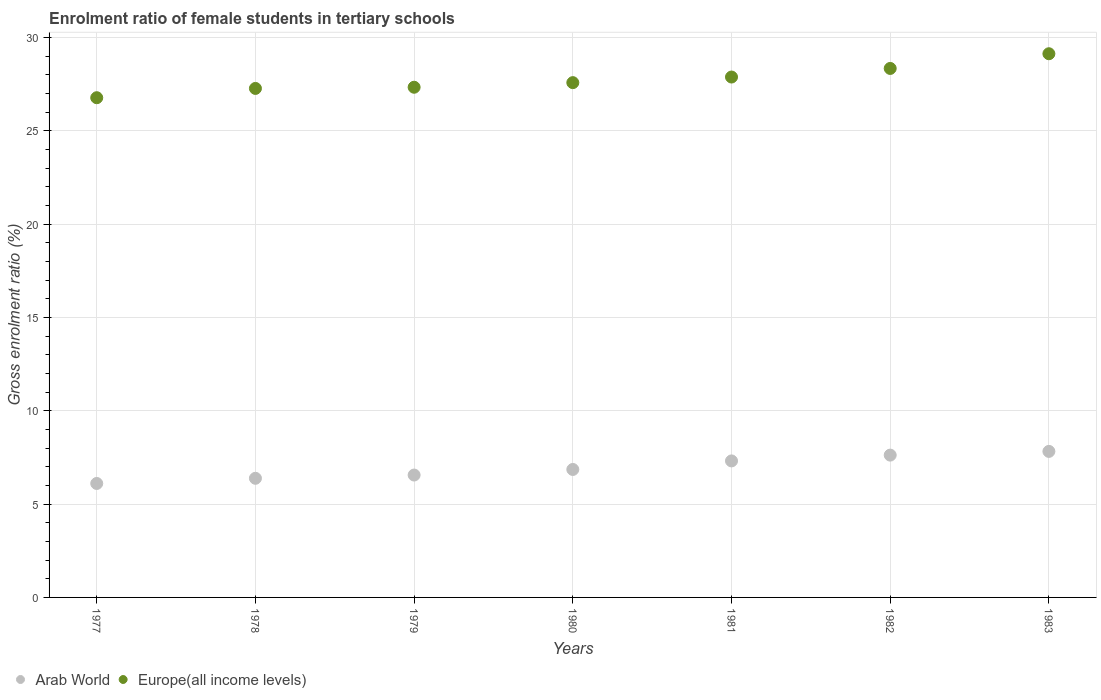How many different coloured dotlines are there?
Provide a short and direct response. 2. What is the enrolment ratio of female students in tertiary schools in Europe(all income levels) in 1980?
Your answer should be compact. 27.59. Across all years, what is the maximum enrolment ratio of female students in tertiary schools in Arab World?
Provide a succinct answer. 7.83. Across all years, what is the minimum enrolment ratio of female students in tertiary schools in Arab World?
Offer a very short reply. 6.11. In which year was the enrolment ratio of female students in tertiary schools in Europe(all income levels) maximum?
Your answer should be compact. 1983. What is the total enrolment ratio of female students in tertiary schools in Europe(all income levels) in the graph?
Offer a terse response. 194.34. What is the difference between the enrolment ratio of female students in tertiary schools in Europe(all income levels) in 1980 and that in 1981?
Ensure brevity in your answer.  -0.3. What is the difference between the enrolment ratio of female students in tertiary schools in Arab World in 1979 and the enrolment ratio of female students in tertiary schools in Europe(all income levels) in 1981?
Ensure brevity in your answer.  -21.33. What is the average enrolment ratio of female students in tertiary schools in Europe(all income levels) per year?
Ensure brevity in your answer.  27.76. In the year 1979, what is the difference between the enrolment ratio of female students in tertiary schools in Europe(all income levels) and enrolment ratio of female students in tertiary schools in Arab World?
Your answer should be very brief. 20.78. In how many years, is the enrolment ratio of female students in tertiary schools in Arab World greater than 19 %?
Your answer should be compact. 0. What is the ratio of the enrolment ratio of female students in tertiary schools in Arab World in 1980 to that in 1982?
Your answer should be very brief. 0.9. What is the difference between the highest and the second highest enrolment ratio of female students in tertiary schools in Europe(all income levels)?
Offer a terse response. 0.79. What is the difference between the highest and the lowest enrolment ratio of female students in tertiary schools in Europe(all income levels)?
Make the answer very short. 2.36. Is the sum of the enrolment ratio of female students in tertiary schools in Europe(all income levels) in 1977 and 1978 greater than the maximum enrolment ratio of female students in tertiary schools in Arab World across all years?
Provide a short and direct response. Yes. Is the enrolment ratio of female students in tertiary schools in Europe(all income levels) strictly greater than the enrolment ratio of female students in tertiary schools in Arab World over the years?
Your answer should be very brief. Yes. How many dotlines are there?
Your answer should be compact. 2. Are the values on the major ticks of Y-axis written in scientific E-notation?
Give a very brief answer. No. Where does the legend appear in the graph?
Make the answer very short. Bottom left. How many legend labels are there?
Ensure brevity in your answer.  2. How are the legend labels stacked?
Give a very brief answer. Horizontal. What is the title of the graph?
Your answer should be compact. Enrolment ratio of female students in tertiary schools. What is the label or title of the X-axis?
Make the answer very short. Years. What is the Gross enrolment ratio (%) of Arab World in 1977?
Provide a short and direct response. 6.11. What is the Gross enrolment ratio (%) in Europe(all income levels) in 1977?
Offer a very short reply. 26.78. What is the Gross enrolment ratio (%) of Arab World in 1978?
Offer a terse response. 6.38. What is the Gross enrolment ratio (%) in Europe(all income levels) in 1978?
Make the answer very short. 27.28. What is the Gross enrolment ratio (%) in Arab World in 1979?
Your answer should be very brief. 6.56. What is the Gross enrolment ratio (%) of Europe(all income levels) in 1979?
Your answer should be compact. 27.34. What is the Gross enrolment ratio (%) of Arab World in 1980?
Make the answer very short. 6.86. What is the Gross enrolment ratio (%) of Europe(all income levels) in 1980?
Offer a very short reply. 27.59. What is the Gross enrolment ratio (%) in Arab World in 1981?
Your answer should be compact. 7.32. What is the Gross enrolment ratio (%) in Europe(all income levels) in 1981?
Provide a short and direct response. 27.89. What is the Gross enrolment ratio (%) in Arab World in 1982?
Provide a succinct answer. 7.63. What is the Gross enrolment ratio (%) in Europe(all income levels) in 1982?
Give a very brief answer. 28.35. What is the Gross enrolment ratio (%) of Arab World in 1983?
Keep it short and to the point. 7.83. What is the Gross enrolment ratio (%) in Europe(all income levels) in 1983?
Make the answer very short. 29.13. Across all years, what is the maximum Gross enrolment ratio (%) of Arab World?
Keep it short and to the point. 7.83. Across all years, what is the maximum Gross enrolment ratio (%) in Europe(all income levels)?
Keep it short and to the point. 29.13. Across all years, what is the minimum Gross enrolment ratio (%) of Arab World?
Provide a short and direct response. 6.11. Across all years, what is the minimum Gross enrolment ratio (%) of Europe(all income levels)?
Your answer should be very brief. 26.78. What is the total Gross enrolment ratio (%) in Arab World in the graph?
Your response must be concise. 48.67. What is the total Gross enrolment ratio (%) in Europe(all income levels) in the graph?
Provide a short and direct response. 194.34. What is the difference between the Gross enrolment ratio (%) in Arab World in 1977 and that in 1978?
Your answer should be compact. -0.28. What is the difference between the Gross enrolment ratio (%) in Europe(all income levels) in 1977 and that in 1978?
Provide a short and direct response. -0.5. What is the difference between the Gross enrolment ratio (%) in Arab World in 1977 and that in 1979?
Give a very brief answer. -0.45. What is the difference between the Gross enrolment ratio (%) of Europe(all income levels) in 1977 and that in 1979?
Offer a terse response. -0.56. What is the difference between the Gross enrolment ratio (%) of Arab World in 1977 and that in 1980?
Your answer should be compact. -0.75. What is the difference between the Gross enrolment ratio (%) of Europe(all income levels) in 1977 and that in 1980?
Keep it short and to the point. -0.81. What is the difference between the Gross enrolment ratio (%) of Arab World in 1977 and that in 1981?
Ensure brevity in your answer.  -1.21. What is the difference between the Gross enrolment ratio (%) in Europe(all income levels) in 1977 and that in 1981?
Your answer should be compact. -1.11. What is the difference between the Gross enrolment ratio (%) of Arab World in 1977 and that in 1982?
Your answer should be compact. -1.52. What is the difference between the Gross enrolment ratio (%) of Europe(all income levels) in 1977 and that in 1982?
Offer a terse response. -1.57. What is the difference between the Gross enrolment ratio (%) in Arab World in 1977 and that in 1983?
Provide a succinct answer. -1.72. What is the difference between the Gross enrolment ratio (%) in Europe(all income levels) in 1977 and that in 1983?
Give a very brief answer. -2.36. What is the difference between the Gross enrolment ratio (%) of Arab World in 1978 and that in 1979?
Your answer should be compact. -0.17. What is the difference between the Gross enrolment ratio (%) of Europe(all income levels) in 1978 and that in 1979?
Your answer should be very brief. -0.06. What is the difference between the Gross enrolment ratio (%) of Arab World in 1978 and that in 1980?
Keep it short and to the point. -0.47. What is the difference between the Gross enrolment ratio (%) in Europe(all income levels) in 1978 and that in 1980?
Provide a succinct answer. -0.31. What is the difference between the Gross enrolment ratio (%) of Arab World in 1978 and that in 1981?
Offer a terse response. -0.93. What is the difference between the Gross enrolment ratio (%) of Europe(all income levels) in 1978 and that in 1981?
Offer a very short reply. -0.61. What is the difference between the Gross enrolment ratio (%) of Arab World in 1978 and that in 1982?
Offer a very short reply. -1.24. What is the difference between the Gross enrolment ratio (%) in Europe(all income levels) in 1978 and that in 1982?
Ensure brevity in your answer.  -1.07. What is the difference between the Gross enrolment ratio (%) in Arab World in 1978 and that in 1983?
Provide a succinct answer. -1.44. What is the difference between the Gross enrolment ratio (%) in Europe(all income levels) in 1978 and that in 1983?
Ensure brevity in your answer.  -1.86. What is the difference between the Gross enrolment ratio (%) of Arab World in 1979 and that in 1980?
Ensure brevity in your answer.  -0.3. What is the difference between the Gross enrolment ratio (%) in Europe(all income levels) in 1979 and that in 1980?
Offer a very short reply. -0.25. What is the difference between the Gross enrolment ratio (%) in Arab World in 1979 and that in 1981?
Your answer should be compact. -0.76. What is the difference between the Gross enrolment ratio (%) of Europe(all income levels) in 1979 and that in 1981?
Offer a very short reply. -0.55. What is the difference between the Gross enrolment ratio (%) in Arab World in 1979 and that in 1982?
Your response must be concise. -1.07. What is the difference between the Gross enrolment ratio (%) in Europe(all income levels) in 1979 and that in 1982?
Keep it short and to the point. -1.01. What is the difference between the Gross enrolment ratio (%) of Arab World in 1979 and that in 1983?
Keep it short and to the point. -1.27. What is the difference between the Gross enrolment ratio (%) of Europe(all income levels) in 1979 and that in 1983?
Your answer should be compact. -1.8. What is the difference between the Gross enrolment ratio (%) in Arab World in 1980 and that in 1981?
Make the answer very short. -0.46. What is the difference between the Gross enrolment ratio (%) of Europe(all income levels) in 1980 and that in 1981?
Offer a very short reply. -0.3. What is the difference between the Gross enrolment ratio (%) in Arab World in 1980 and that in 1982?
Your answer should be very brief. -0.77. What is the difference between the Gross enrolment ratio (%) in Europe(all income levels) in 1980 and that in 1982?
Your answer should be very brief. -0.76. What is the difference between the Gross enrolment ratio (%) of Arab World in 1980 and that in 1983?
Your answer should be very brief. -0.97. What is the difference between the Gross enrolment ratio (%) in Europe(all income levels) in 1980 and that in 1983?
Your answer should be very brief. -1.55. What is the difference between the Gross enrolment ratio (%) in Arab World in 1981 and that in 1982?
Give a very brief answer. -0.31. What is the difference between the Gross enrolment ratio (%) of Europe(all income levels) in 1981 and that in 1982?
Provide a succinct answer. -0.46. What is the difference between the Gross enrolment ratio (%) in Arab World in 1981 and that in 1983?
Provide a short and direct response. -0.51. What is the difference between the Gross enrolment ratio (%) in Europe(all income levels) in 1981 and that in 1983?
Give a very brief answer. -1.25. What is the difference between the Gross enrolment ratio (%) of Arab World in 1982 and that in 1983?
Keep it short and to the point. -0.2. What is the difference between the Gross enrolment ratio (%) of Europe(all income levels) in 1982 and that in 1983?
Offer a very short reply. -0.79. What is the difference between the Gross enrolment ratio (%) in Arab World in 1977 and the Gross enrolment ratio (%) in Europe(all income levels) in 1978?
Your answer should be very brief. -21.17. What is the difference between the Gross enrolment ratio (%) in Arab World in 1977 and the Gross enrolment ratio (%) in Europe(all income levels) in 1979?
Provide a succinct answer. -21.23. What is the difference between the Gross enrolment ratio (%) of Arab World in 1977 and the Gross enrolment ratio (%) of Europe(all income levels) in 1980?
Your response must be concise. -21.48. What is the difference between the Gross enrolment ratio (%) of Arab World in 1977 and the Gross enrolment ratio (%) of Europe(all income levels) in 1981?
Your response must be concise. -21.78. What is the difference between the Gross enrolment ratio (%) in Arab World in 1977 and the Gross enrolment ratio (%) in Europe(all income levels) in 1982?
Keep it short and to the point. -22.24. What is the difference between the Gross enrolment ratio (%) of Arab World in 1977 and the Gross enrolment ratio (%) of Europe(all income levels) in 1983?
Your answer should be compact. -23.03. What is the difference between the Gross enrolment ratio (%) in Arab World in 1978 and the Gross enrolment ratio (%) in Europe(all income levels) in 1979?
Provide a short and direct response. -20.95. What is the difference between the Gross enrolment ratio (%) of Arab World in 1978 and the Gross enrolment ratio (%) of Europe(all income levels) in 1980?
Make the answer very short. -21.2. What is the difference between the Gross enrolment ratio (%) of Arab World in 1978 and the Gross enrolment ratio (%) of Europe(all income levels) in 1981?
Provide a short and direct response. -21.5. What is the difference between the Gross enrolment ratio (%) in Arab World in 1978 and the Gross enrolment ratio (%) in Europe(all income levels) in 1982?
Ensure brevity in your answer.  -21.96. What is the difference between the Gross enrolment ratio (%) in Arab World in 1978 and the Gross enrolment ratio (%) in Europe(all income levels) in 1983?
Your answer should be compact. -22.75. What is the difference between the Gross enrolment ratio (%) of Arab World in 1979 and the Gross enrolment ratio (%) of Europe(all income levels) in 1980?
Make the answer very short. -21.03. What is the difference between the Gross enrolment ratio (%) of Arab World in 1979 and the Gross enrolment ratio (%) of Europe(all income levels) in 1981?
Make the answer very short. -21.33. What is the difference between the Gross enrolment ratio (%) in Arab World in 1979 and the Gross enrolment ratio (%) in Europe(all income levels) in 1982?
Make the answer very short. -21.79. What is the difference between the Gross enrolment ratio (%) in Arab World in 1979 and the Gross enrolment ratio (%) in Europe(all income levels) in 1983?
Your response must be concise. -22.58. What is the difference between the Gross enrolment ratio (%) in Arab World in 1980 and the Gross enrolment ratio (%) in Europe(all income levels) in 1981?
Ensure brevity in your answer.  -21.03. What is the difference between the Gross enrolment ratio (%) in Arab World in 1980 and the Gross enrolment ratio (%) in Europe(all income levels) in 1982?
Give a very brief answer. -21.49. What is the difference between the Gross enrolment ratio (%) in Arab World in 1980 and the Gross enrolment ratio (%) in Europe(all income levels) in 1983?
Make the answer very short. -22.28. What is the difference between the Gross enrolment ratio (%) in Arab World in 1981 and the Gross enrolment ratio (%) in Europe(all income levels) in 1982?
Your response must be concise. -21.03. What is the difference between the Gross enrolment ratio (%) of Arab World in 1981 and the Gross enrolment ratio (%) of Europe(all income levels) in 1983?
Give a very brief answer. -21.82. What is the difference between the Gross enrolment ratio (%) of Arab World in 1982 and the Gross enrolment ratio (%) of Europe(all income levels) in 1983?
Your answer should be very brief. -21.51. What is the average Gross enrolment ratio (%) of Arab World per year?
Your response must be concise. 6.95. What is the average Gross enrolment ratio (%) in Europe(all income levels) per year?
Provide a succinct answer. 27.76. In the year 1977, what is the difference between the Gross enrolment ratio (%) in Arab World and Gross enrolment ratio (%) in Europe(all income levels)?
Your answer should be very brief. -20.67. In the year 1978, what is the difference between the Gross enrolment ratio (%) of Arab World and Gross enrolment ratio (%) of Europe(all income levels)?
Give a very brief answer. -20.89. In the year 1979, what is the difference between the Gross enrolment ratio (%) in Arab World and Gross enrolment ratio (%) in Europe(all income levels)?
Offer a terse response. -20.78. In the year 1980, what is the difference between the Gross enrolment ratio (%) of Arab World and Gross enrolment ratio (%) of Europe(all income levels)?
Keep it short and to the point. -20.73. In the year 1981, what is the difference between the Gross enrolment ratio (%) in Arab World and Gross enrolment ratio (%) in Europe(all income levels)?
Give a very brief answer. -20.57. In the year 1982, what is the difference between the Gross enrolment ratio (%) in Arab World and Gross enrolment ratio (%) in Europe(all income levels)?
Your answer should be compact. -20.72. In the year 1983, what is the difference between the Gross enrolment ratio (%) in Arab World and Gross enrolment ratio (%) in Europe(all income levels)?
Your response must be concise. -21.31. What is the ratio of the Gross enrolment ratio (%) in Arab World in 1977 to that in 1978?
Offer a terse response. 0.96. What is the ratio of the Gross enrolment ratio (%) of Europe(all income levels) in 1977 to that in 1978?
Provide a short and direct response. 0.98. What is the ratio of the Gross enrolment ratio (%) in Arab World in 1977 to that in 1979?
Make the answer very short. 0.93. What is the ratio of the Gross enrolment ratio (%) of Europe(all income levels) in 1977 to that in 1979?
Offer a terse response. 0.98. What is the ratio of the Gross enrolment ratio (%) of Arab World in 1977 to that in 1980?
Give a very brief answer. 0.89. What is the ratio of the Gross enrolment ratio (%) in Europe(all income levels) in 1977 to that in 1980?
Provide a succinct answer. 0.97. What is the ratio of the Gross enrolment ratio (%) of Arab World in 1977 to that in 1981?
Give a very brief answer. 0.83. What is the ratio of the Gross enrolment ratio (%) of Europe(all income levels) in 1977 to that in 1981?
Keep it short and to the point. 0.96. What is the ratio of the Gross enrolment ratio (%) of Arab World in 1977 to that in 1982?
Your answer should be compact. 0.8. What is the ratio of the Gross enrolment ratio (%) of Europe(all income levels) in 1977 to that in 1982?
Keep it short and to the point. 0.94. What is the ratio of the Gross enrolment ratio (%) in Arab World in 1977 to that in 1983?
Your answer should be compact. 0.78. What is the ratio of the Gross enrolment ratio (%) in Europe(all income levels) in 1977 to that in 1983?
Offer a very short reply. 0.92. What is the ratio of the Gross enrolment ratio (%) in Arab World in 1978 to that in 1979?
Provide a succinct answer. 0.97. What is the ratio of the Gross enrolment ratio (%) of Europe(all income levels) in 1978 to that in 1979?
Your answer should be very brief. 1. What is the ratio of the Gross enrolment ratio (%) of Arab World in 1978 to that in 1980?
Offer a terse response. 0.93. What is the ratio of the Gross enrolment ratio (%) in Europe(all income levels) in 1978 to that in 1980?
Provide a succinct answer. 0.99. What is the ratio of the Gross enrolment ratio (%) of Arab World in 1978 to that in 1981?
Offer a terse response. 0.87. What is the ratio of the Gross enrolment ratio (%) in Europe(all income levels) in 1978 to that in 1981?
Your answer should be very brief. 0.98. What is the ratio of the Gross enrolment ratio (%) of Arab World in 1978 to that in 1982?
Provide a succinct answer. 0.84. What is the ratio of the Gross enrolment ratio (%) in Europe(all income levels) in 1978 to that in 1982?
Your response must be concise. 0.96. What is the ratio of the Gross enrolment ratio (%) in Arab World in 1978 to that in 1983?
Make the answer very short. 0.82. What is the ratio of the Gross enrolment ratio (%) of Europe(all income levels) in 1978 to that in 1983?
Your response must be concise. 0.94. What is the ratio of the Gross enrolment ratio (%) of Arab World in 1979 to that in 1980?
Give a very brief answer. 0.96. What is the ratio of the Gross enrolment ratio (%) of Arab World in 1979 to that in 1981?
Provide a succinct answer. 0.9. What is the ratio of the Gross enrolment ratio (%) of Europe(all income levels) in 1979 to that in 1981?
Give a very brief answer. 0.98. What is the ratio of the Gross enrolment ratio (%) in Arab World in 1979 to that in 1982?
Make the answer very short. 0.86. What is the ratio of the Gross enrolment ratio (%) of Europe(all income levels) in 1979 to that in 1982?
Your answer should be compact. 0.96. What is the ratio of the Gross enrolment ratio (%) in Arab World in 1979 to that in 1983?
Keep it short and to the point. 0.84. What is the ratio of the Gross enrolment ratio (%) in Europe(all income levels) in 1979 to that in 1983?
Your answer should be very brief. 0.94. What is the ratio of the Gross enrolment ratio (%) in Arab World in 1980 to that in 1981?
Keep it short and to the point. 0.94. What is the ratio of the Gross enrolment ratio (%) of Europe(all income levels) in 1980 to that in 1981?
Give a very brief answer. 0.99. What is the ratio of the Gross enrolment ratio (%) in Arab World in 1980 to that in 1982?
Ensure brevity in your answer.  0.9. What is the ratio of the Gross enrolment ratio (%) of Europe(all income levels) in 1980 to that in 1982?
Your answer should be compact. 0.97. What is the ratio of the Gross enrolment ratio (%) in Arab World in 1980 to that in 1983?
Keep it short and to the point. 0.88. What is the ratio of the Gross enrolment ratio (%) in Europe(all income levels) in 1980 to that in 1983?
Keep it short and to the point. 0.95. What is the ratio of the Gross enrolment ratio (%) in Arab World in 1981 to that in 1982?
Provide a succinct answer. 0.96. What is the ratio of the Gross enrolment ratio (%) of Europe(all income levels) in 1981 to that in 1982?
Offer a terse response. 0.98. What is the ratio of the Gross enrolment ratio (%) in Arab World in 1981 to that in 1983?
Offer a very short reply. 0.93. What is the ratio of the Gross enrolment ratio (%) of Europe(all income levels) in 1981 to that in 1983?
Offer a very short reply. 0.96. What is the ratio of the Gross enrolment ratio (%) in Arab World in 1982 to that in 1983?
Keep it short and to the point. 0.97. What is the difference between the highest and the second highest Gross enrolment ratio (%) of Arab World?
Provide a succinct answer. 0.2. What is the difference between the highest and the second highest Gross enrolment ratio (%) of Europe(all income levels)?
Offer a terse response. 0.79. What is the difference between the highest and the lowest Gross enrolment ratio (%) of Arab World?
Keep it short and to the point. 1.72. What is the difference between the highest and the lowest Gross enrolment ratio (%) in Europe(all income levels)?
Offer a terse response. 2.36. 